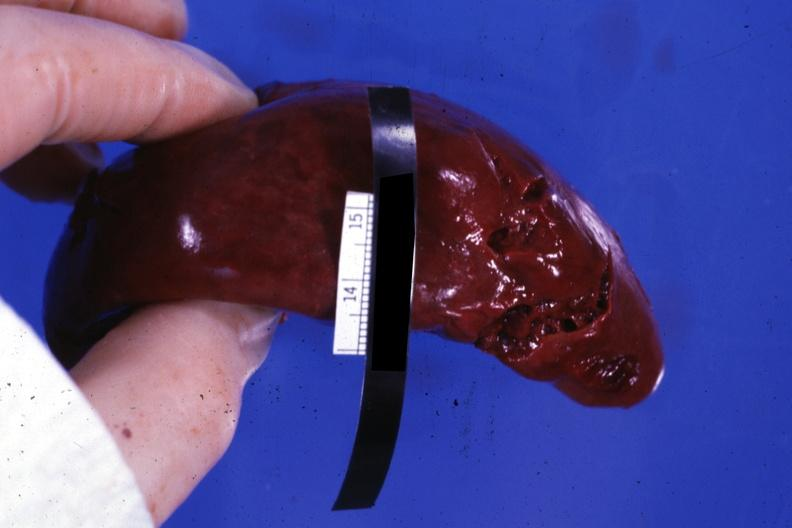s hematologic present?
Answer the question using a single word or phrase. Yes 